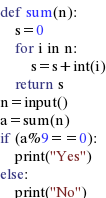Convert code to text. <code><loc_0><loc_0><loc_500><loc_500><_Python_>def sum(n):
    s=0
    for i in n:
        s=s+int(i)
    return s
n=input()
a=sum(n)
if (a%9==0):
    print("Yes")
else:
    print("No")</code> 